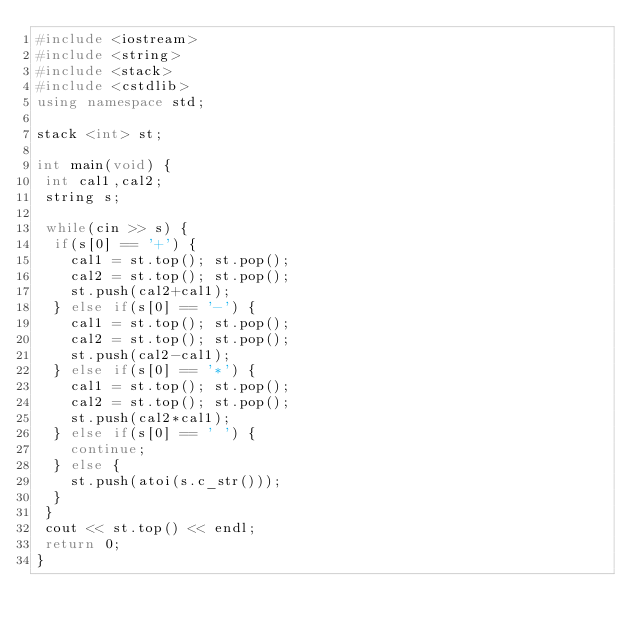Convert code to text. <code><loc_0><loc_0><loc_500><loc_500><_C++_>#include <iostream>
#include <string>
#include <stack>
#include <cstdlib>
using namespace std;

stack <int> st;

int main(void) {
 int cal1,cal2;
 string s;

 while(cin >> s) {
  if(s[0] == '+') {
    cal1 = st.top(); st.pop();
    cal2 = st.top(); st.pop();
    st.push(cal2+cal1);
  } else if(s[0] == '-') {
    cal1 = st.top(); st.pop();
    cal2 = st.top(); st.pop();
    st.push(cal2-cal1);
  } else if(s[0] == '*') {
    cal1 = st.top(); st.pop();
    cal2 = st.top(); st.pop();
    st.push(cal2*cal1);
  } else if(s[0] == ' ') {
    continue;
  } else {
    st.push(atoi(s.c_str()));
  }
 }
 cout << st.top() << endl;
 return 0;
}</code> 